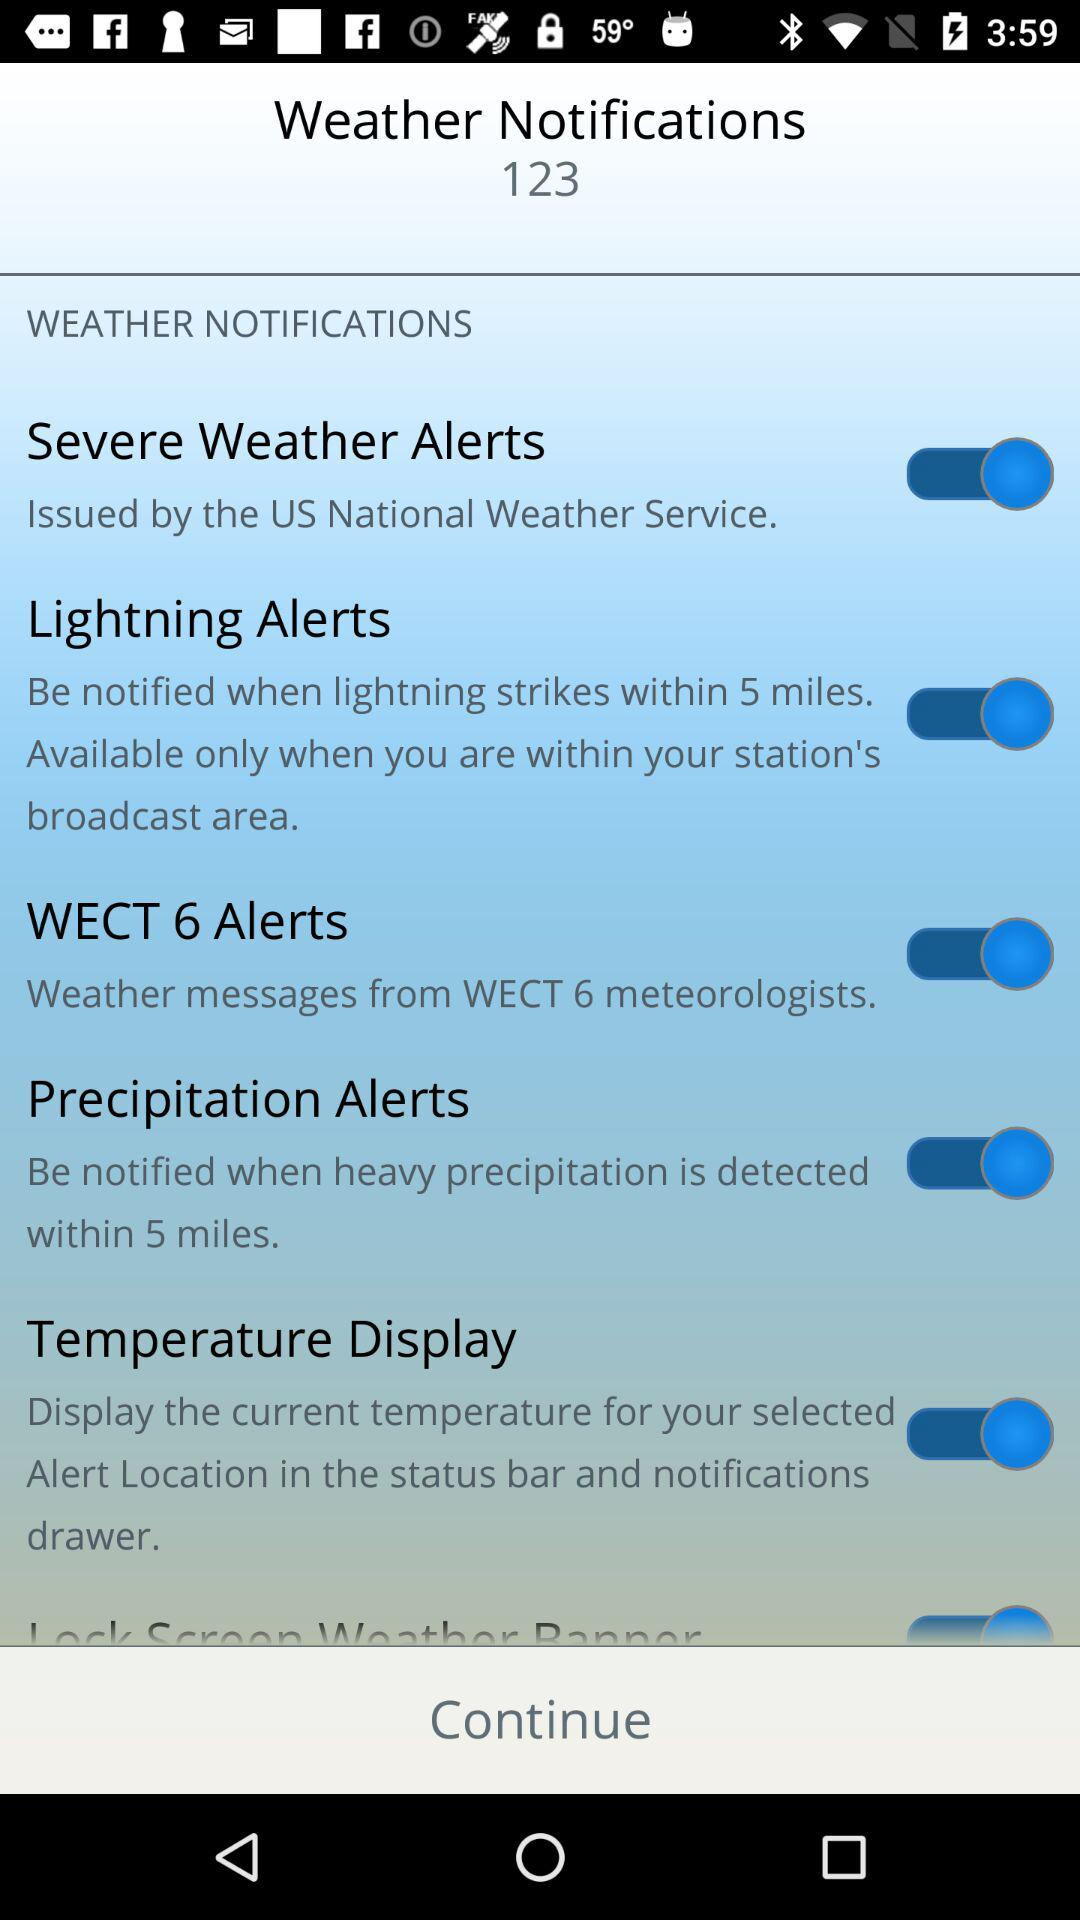What is the status of "Temperature Display"? The status is "on". 